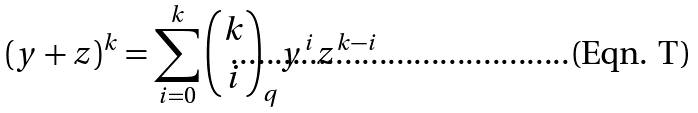<formula> <loc_0><loc_0><loc_500><loc_500>( y + z ) ^ { k } = \sum _ { i = 0 } ^ { k } \binom { k } { i } _ { q } y ^ { i } z ^ { k - i }</formula> 